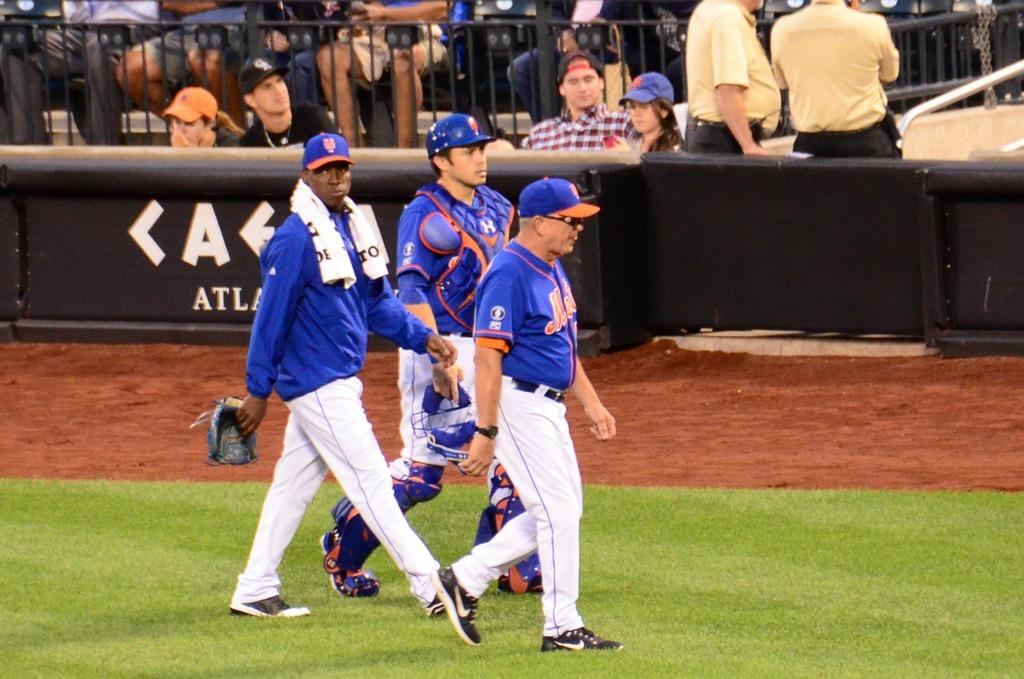<image>
Create a compact narrative representing the image presented. a fe people walking that have Mets gear on 